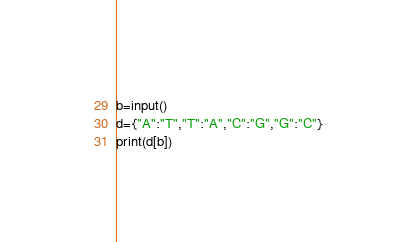Convert code to text. <code><loc_0><loc_0><loc_500><loc_500><_Python_>b=input()
d={"A":"T","T":"A","C":"G","G":"C"}
print(d[b])</code> 